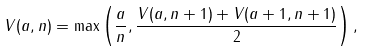Convert formula to latex. <formula><loc_0><loc_0><loc_500><loc_500>V ( a , n ) = \max \left ( \frac { a } { n } , \frac { V ( a , n + 1 ) + V ( a + 1 , n + 1 ) } 2 \right ) ,</formula> 